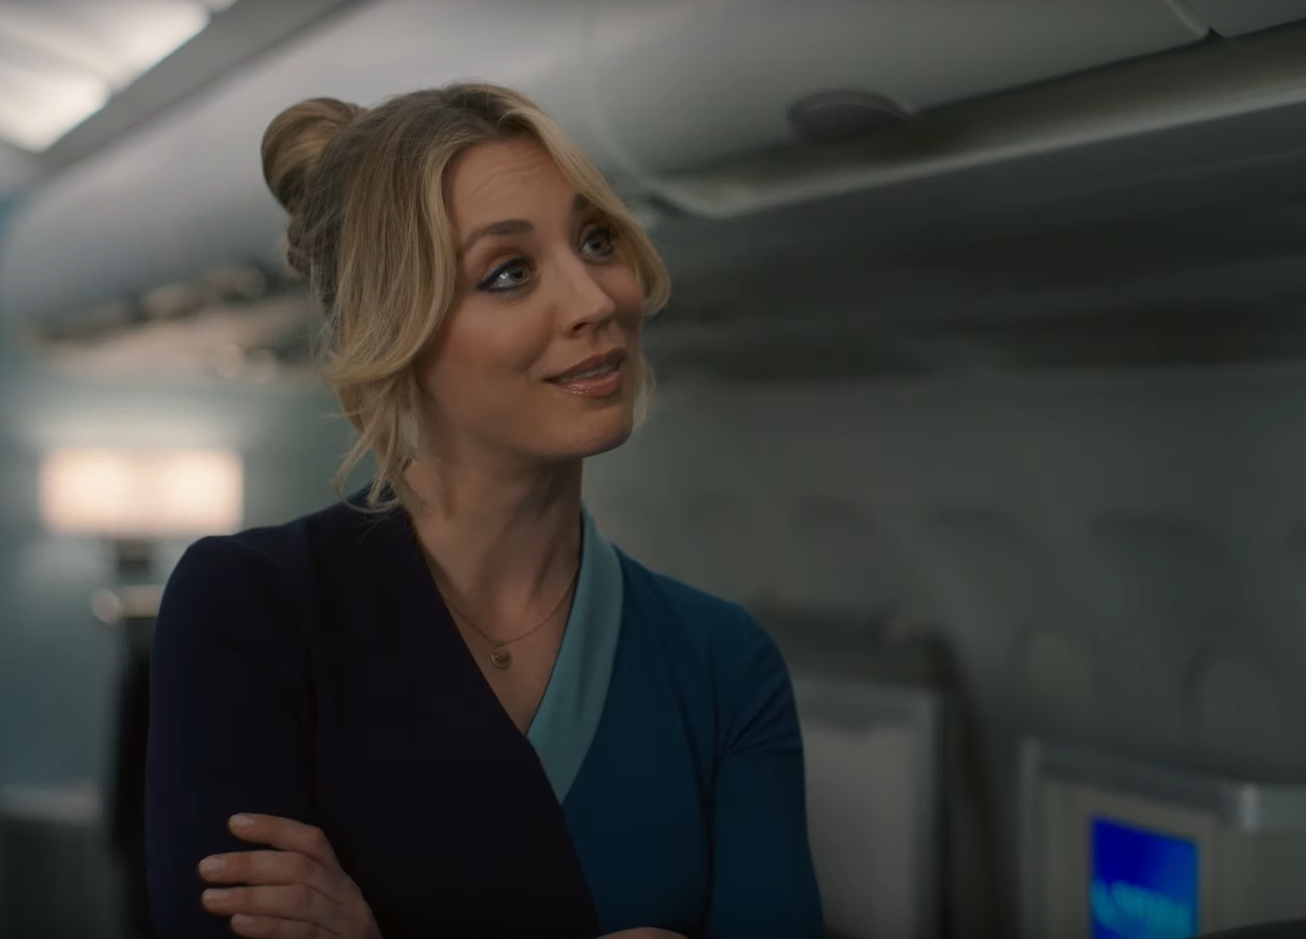What might this person's role be on the aircraft? Based on the uniform and her location in the cabin, the individual appears to be playing the role of a flight attendant. Her attire suggests professionalism and authority, which are important for managing safety and providing service to passengers during a flight. 